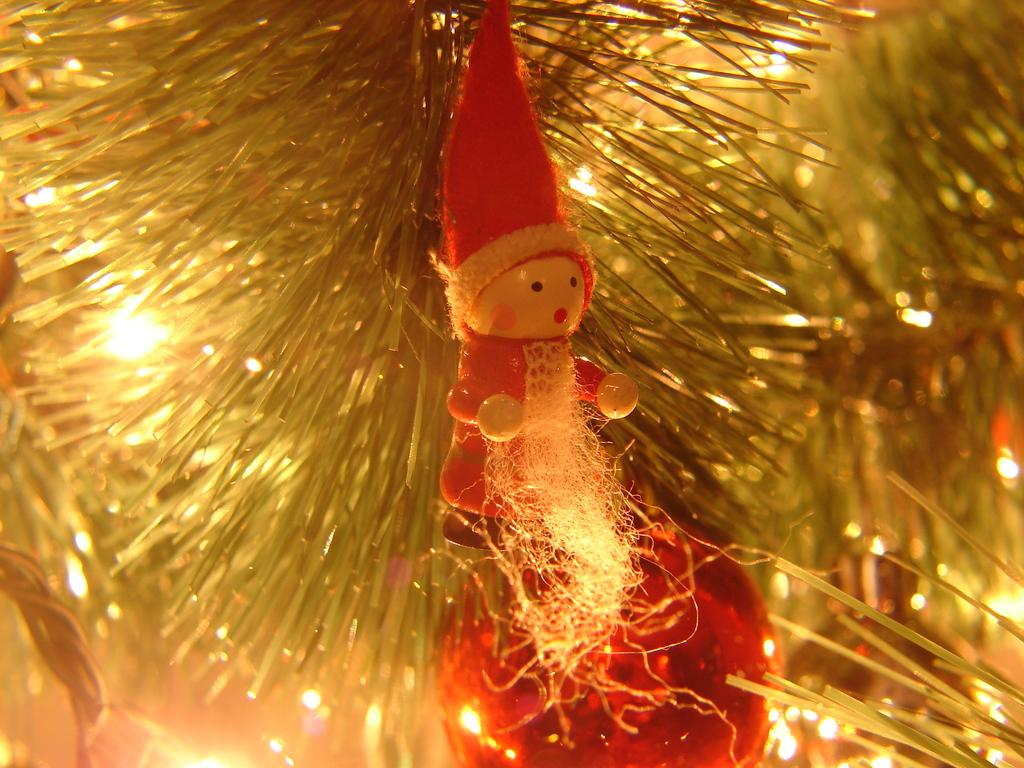What is the main subject in the image? There is a doll in the image. What other items can be seen in the image besides the doll? There are decorative items and lights in the image. Can you describe the background of the image? The background of the image is blurred. What type of quartz can be seen in the image? There is no quartz present in the image. How does the doll affect the passenger's throat in the image? There is no passenger or throat mentioned in the image; it only features a doll, decorative items, lights, and a blurred background. 